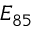<formula> <loc_0><loc_0><loc_500><loc_500>E _ { 8 5 }</formula> 